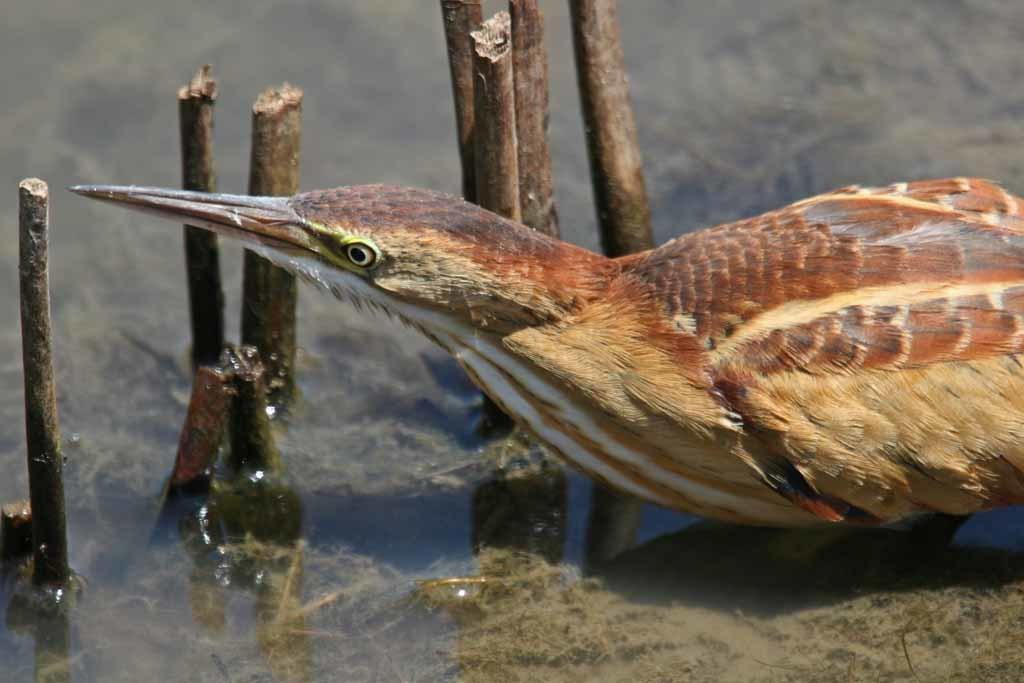What type of animal can be seen on the right side of the image? There is a bird on the right side of the image. What objects are visible in the image besides the bird? There are sticks visible in the image. What can be seen in the background of the image? There is water in the background of the image. What type of crime is the bird committing in the image? There is no crime being committed in the image; it simply features a bird and some sticks. Can you tell me how many horses are present in the image? There are no horses present in the image. 